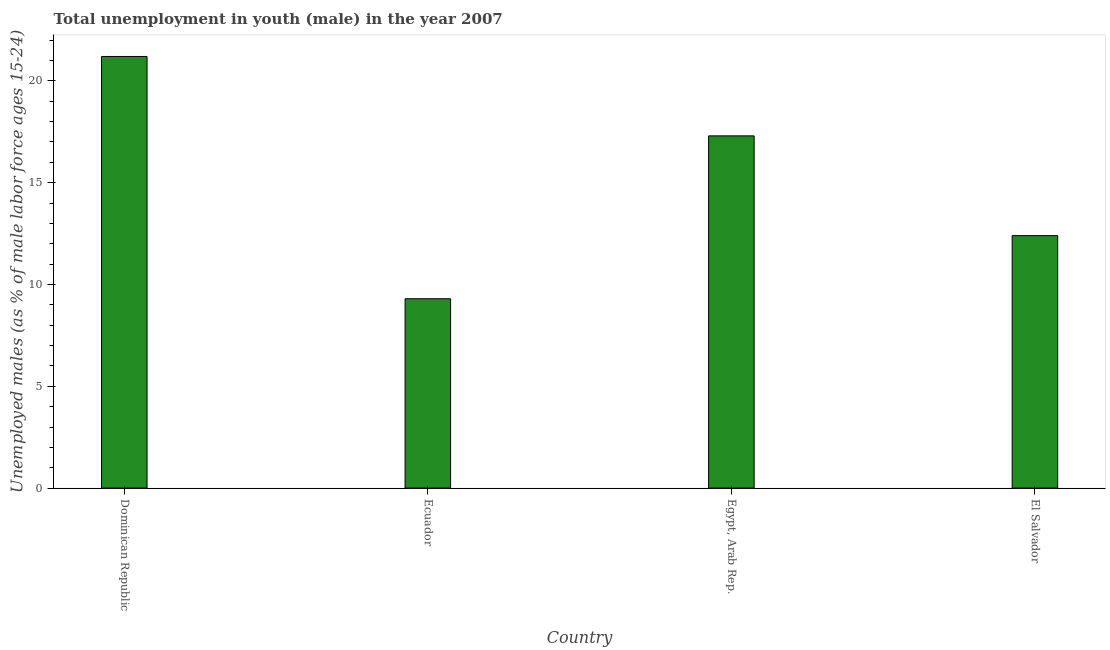Does the graph contain any zero values?
Keep it short and to the point. No. What is the title of the graph?
Offer a very short reply. Total unemployment in youth (male) in the year 2007. What is the label or title of the Y-axis?
Keep it short and to the point. Unemployed males (as % of male labor force ages 15-24). What is the unemployed male youth population in El Salvador?
Give a very brief answer. 12.4. Across all countries, what is the maximum unemployed male youth population?
Ensure brevity in your answer.  21.2. Across all countries, what is the minimum unemployed male youth population?
Your answer should be very brief. 9.3. In which country was the unemployed male youth population maximum?
Your answer should be compact. Dominican Republic. In which country was the unemployed male youth population minimum?
Your answer should be compact. Ecuador. What is the sum of the unemployed male youth population?
Your response must be concise. 60.2. What is the difference between the unemployed male youth population in Dominican Republic and El Salvador?
Provide a succinct answer. 8.8. What is the average unemployed male youth population per country?
Provide a succinct answer. 15.05. What is the median unemployed male youth population?
Provide a short and direct response. 14.85. What is the ratio of the unemployed male youth population in Dominican Republic to that in Ecuador?
Keep it short and to the point. 2.28. Is the sum of the unemployed male youth population in Dominican Republic and El Salvador greater than the maximum unemployed male youth population across all countries?
Provide a succinct answer. Yes. In how many countries, is the unemployed male youth population greater than the average unemployed male youth population taken over all countries?
Your answer should be compact. 2. How many bars are there?
Give a very brief answer. 4. What is the difference between two consecutive major ticks on the Y-axis?
Your answer should be compact. 5. Are the values on the major ticks of Y-axis written in scientific E-notation?
Keep it short and to the point. No. What is the Unemployed males (as % of male labor force ages 15-24) in Dominican Republic?
Ensure brevity in your answer.  21.2. What is the Unemployed males (as % of male labor force ages 15-24) in Ecuador?
Offer a terse response. 9.3. What is the Unemployed males (as % of male labor force ages 15-24) in Egypt, Arab Rep.?
Your answer should be compact. 17.3. What is the Unemployed males (as % of male labor force ages 15-24) of El Salvador?
Provide a succinct answer. 12.4. What is the difference between the Unemployed males (as % of male labor force ages 15-24) in Dominican Republic and Egypt, Arab Rep.?
Offer a very short reply. 3.9. What is the difference between the Unemployed males (as % of male labor force ages 15-24) in Ecuador and El Salvador?
Make the answer very short. -3.1. What is the difference between the Unemployed males (as % of male labor force ages 15-24) in Egypt, Arab Rep. and El Salvador?
Your answer should be compact. 4.9. What is the ratio of the Unemployed males (as % of male labor force ages 15-24) in Dominican Republic to that in Ecuador?
Make the answer very short. 2.28. What is the ratio of the Unemployed males (as % of male labor force ages 15-24) in Dominican Republic to that in Egypt, Arab Rep.?
Offer a terse response. 1.23. What is the ratio of the Unemployed males (as % of male labor force ages 15-24) in Dominican Republic to that in El Salvador?
Make the answer very short. 1.71. What is the ratio of the Unemployed males (as % of male labor force ages 15-24) in Ecuador to that in Egypt, Arab Rep.?
Offer a terse response. 0.54. What is the ratio of the Unemployed males (as % of male labor force ages 15-24) in Egypt, Arab Rep. to that in El Salvador?
Your answer should be compact. 1.4. 